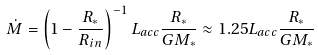<formula> <loc_0><loc_0><loc_500><loc_500>\dot { M } = \left ( 1 - \frac { R _ { * } } { R _ { i n } } \right ) ^ { - 1 } L _ { a c c } \frac { R _ { * } } { G M _ { * } } \approx 1 . 2 5 L _ { a c c } \frac { R _ { * } } { G M _ { * } }</formula> 